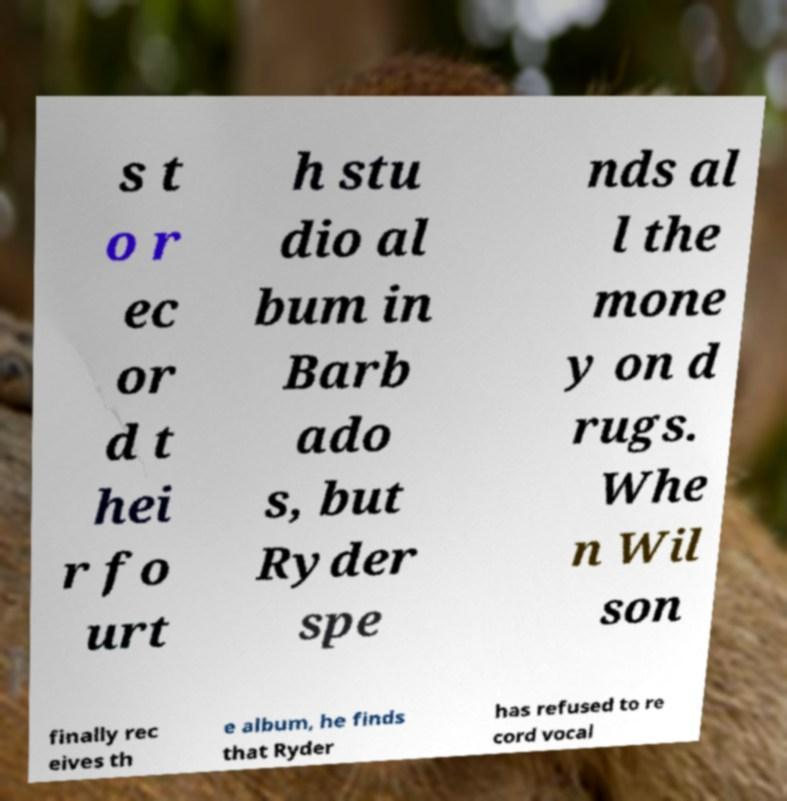What messages or text are displayed in this image? I need them in a readable, typed format. s t o r ec or d t hei r fo urt h stu dio al bum in Barb ado s, but Ryder spe nds al l the mone y on d rugs. Whe n Wil son finally rec eives th e album, he finds that Ryder has refused to re cord vocal 